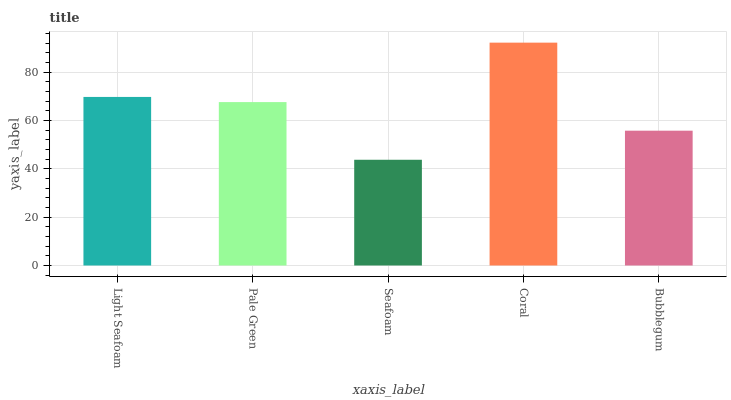Is Seafoam the minimum?
Answer yes or no. Yes. Is Coral the maximum?
Answer yes or no. Yes. Is Pale Green the minimum?
Answer yes or no. No. Is Pale Green the maximum?
Answer yes or no. No. Is Light Seafoam greater than Pale Green?
Answer yes or no. Yes. Is Pale Green less than Light Seafoam?
Answer yes or no. Yes. Is Pale Green greater than Light Seafoam?
Answer yes or no. No. Is Light Seafoam less than Pale Green?
Answer yes or no. No. Is Pale Green the high median?
Answer yes or no. Yes. Is Pale Green the low median?
Answer yes or no. Yes. Is Coral the high median?
Answer yes or no. No. Is Coral the low median?
Answer yes or no. No. 